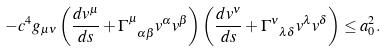Convert formula to latex. <formula><loc_0><loc_0><loc_500><loc_500>- c ^ { 4 } g _ { \mu \nu } \left ( \frac { d v ^ { \mu } } { d s } + \Gamma _ { \ \alpha \beta } ^ { \mu } v ^ { \alpha } v ^ { \beta } \right ) \left ( \frac { d v ^ { \nu } } { d s } + \Gamma _ { \ \lambda \delta } ^ { \nu } v ^ { \lambda } v ^ { \delta } \right ) \leq a _ { 0 } ^ { 2 } .</formula> 